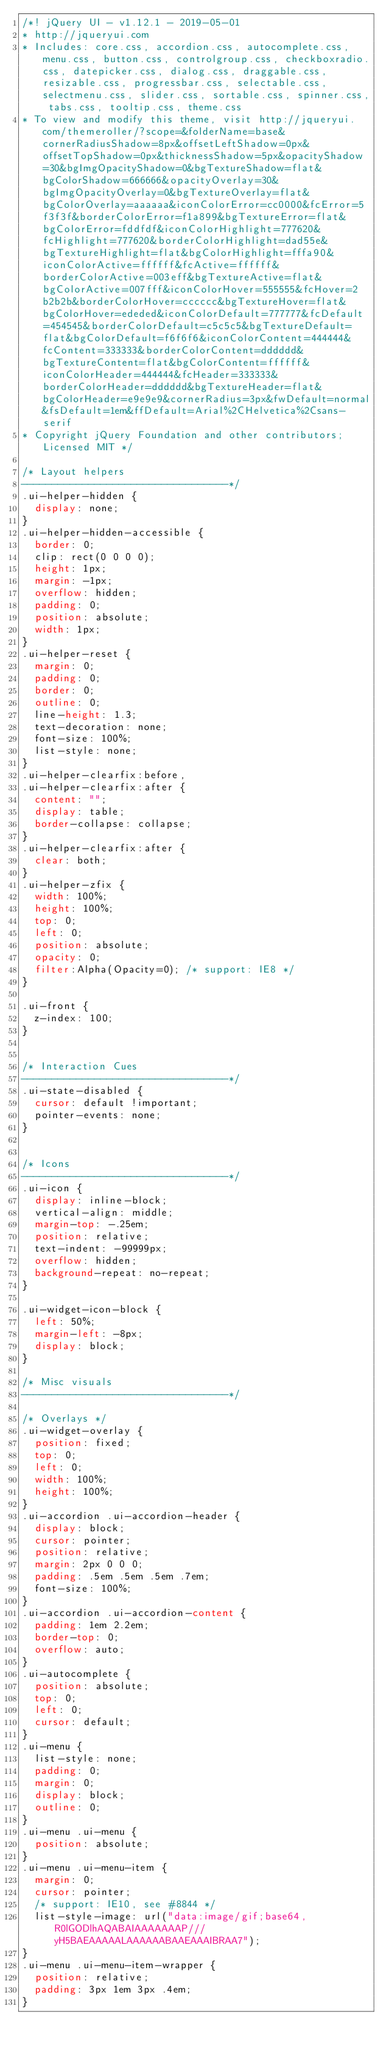<code> <loc_0><loc_0><loc_500><loc_500><_CSS_>/*! jQuery UI - v1.12.1 - 2019-05-01
* http://jqueryui.com
* Includes: core.css, accordion.css, autocomplete.css, menu.css, button.css, controlgroup.css, checkboxradio.css, datepicker.css, dialog.css, draggable.css, resizable.css, progressbar.css, selectable.css, selectmenu.css, slider.css, sortable.css, spinner.css, tabs.css, tooltip.css, theme.css
* To view and modify this theme, visit http://jqueryui.com/themeroller/?scope=&folderName=base&cornerRadiusShadow=8px&offsetLeftShadow=0px&offsetTopShadow=0px&thicknessShadow=5px&opacityShadow=30&bgImgOpacityShadow=0&bgTextureShadow=flat&bgColorShadow=666666&opacityOverlay=30&bgImgOpacityOverlay=0&bgTextureOverlay=flat&bgColorOverlay=aaaaaa&iconColorError=cc0000&fcError=5f3f3f&borderColorError=f1a899&bgTextureError=flat&bgColorError=fddfdf&iconColorHighlight=777620&fcHighlight=777620&borderColorHighlight=dad55e&bgTextureHighlight=flat&bgColorHighlight=fffa90&iconColorActive=ffffff&fcActive=ffffff&borderColorActive=003eff&bgTextureActive=flat&bgColorActive=007fff&iconColorHover=555555&fcHover=2b2b2b&borderColorHover=cccccc&bgTextureHover=flat&bgColorHover=ededed&iconColorDefault=777777&fcDefault=454545&borderColorDefault=c5c5c5&bgTextureDefault=flat&bgColorDefault=f6f6f6&iconColorContent=444444&fcContent=333333&borderColorContent=dddddd&bgTextureContent=flat&bgColorContent=ffffff&iconColorHeader=444444&fcHeader=333333&borderColorHeader=dddddd&bgTextureHeader=flat&bgColorHeader=e9e9e9&cornerRadius=3px&fwDefault=normal&fsDefault=1em&ffDefault=Arial%2CHelvetica%2Csans-serif
* Copyright jQuery Foundation and other contributors; Licensed MIT */

/* Layout helpers
----------------------------------*/
.ui-helper-hidden {
	display: none;
}
.ui-helper-hidden-accessible {
	border: 0;
	clip: rect(0 0 0 0);
	height: 1px;
	margin: -1px;
	overflow: hidden;
	padding: 0;
	position: absolute;
	width: 1px;
}
.ui-helper-reset {
	margin: 0;
	padding: 0;
	border: 0;
	outline: 0;
	line-height: 1.3;
	text-decoration: none;
	font-size: 100%;
	list-style: none;
}
.ui-helper-clearfix:before,
.ui-helper-clearfix:after {
	content: "";
	display: table;
	border-collapse: collapse;
}
.ui-helper-clearfix:after {
	clear: both;
}
.ui-helper-zfix {
	width: 100%;
	height: 100%;
	top: 0;
	left: 0;
	position: absolute;
	opacity: 0;
	filter:Alpha(Opacity=0); /* support: IE8 */
}

.ui-front {
	z-index: 100;
}


/* Interaction Cues
----------------------------------*/
.ui-state-disabled {
	cursor: default !important;
	pointer-events: none;
}


/* Icons
----------------------------------*/
.ui-icon {
	display: inline-block;
	vertical-align: middle;
	margin-top: -.25em;
	position: relative;
	text-indent: -99999px;
	overflow: hidden;
	background-repeat: no-repeat;
}

.ui-widget-icon-block {
	left: 50%;
	margin-left: -8px;
	display: block;
}

/* Misc visuals
----------------------------------*/

/* Overlays */
.ui-widget-overlay {
	position: fixed;
	top: 0;
	left: 0;
	width: 100%;
	height: 100%;
}
.ui-accordion .ui-accordion-header {
	display: block;
	cursor: pointer;
	position: relative;
	margin: 2px 0 0 0;
	padding: .5em .5em .5em .7em;
	font-size: 100%;
}
.ui-accordion .ui-accordion-content {
	padding: 1em 2.2em;
	border-top: 0;
	overflow: auto;
}
.ui-autocomplete {
	position: absolute;
	top: 0;
	left: 0;
	cursor: default;
}
.ui-menu {
	list-style: none;
	padding: 0;
	margin: 0;
	display: block;
	outline: 0;
}
.ui-menu .ui-menu {
	position: absolute;
}
.ui-menu .ui-menu-item {
	margin: 0;
	cursor: pointer;
	/* support: IE10, see #8844 */
	list-style-image: url("data:image/gif;base64,R0lGODlhAQABAIAAAAAAAP///yH5BAEAAAAALAAAAAABAAEAAAIBRAA7");
}
.ui-menu .ui-menu-item-wrapper {
	position: relative;
	padding: 3px 1em 3px .4em;
}</code> 